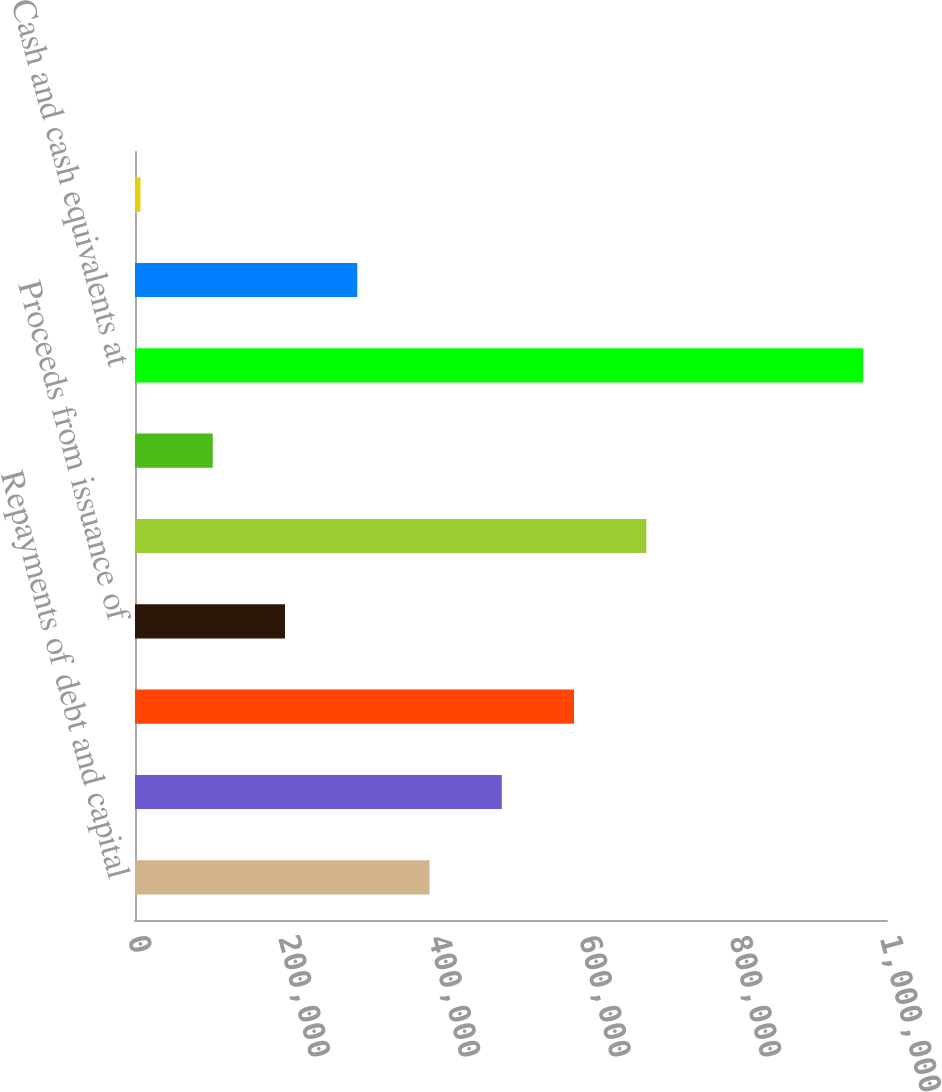<chart> <loc_0><loc_0><loc_500><loc_500><bar_chart><fcel>Repayments of debt and capital<fcel>Proceeds from foreign grants<fcel>Proceeds from sale leaseback<fcel>Proceeds from issuance of<fcel>Net cash provided by financing<fcel>Effect of exchange rate<fcel>Cash and cash equivalents at<fcel>Interest net of amounts<fcel>Incometaxes<nl><fcel>391659<fcel>487746<fcel>583833<fcel>199484<fcel>679921<fcel>103396<fcel>968183<fcel>295571<fcel>7309<nl></chart> 